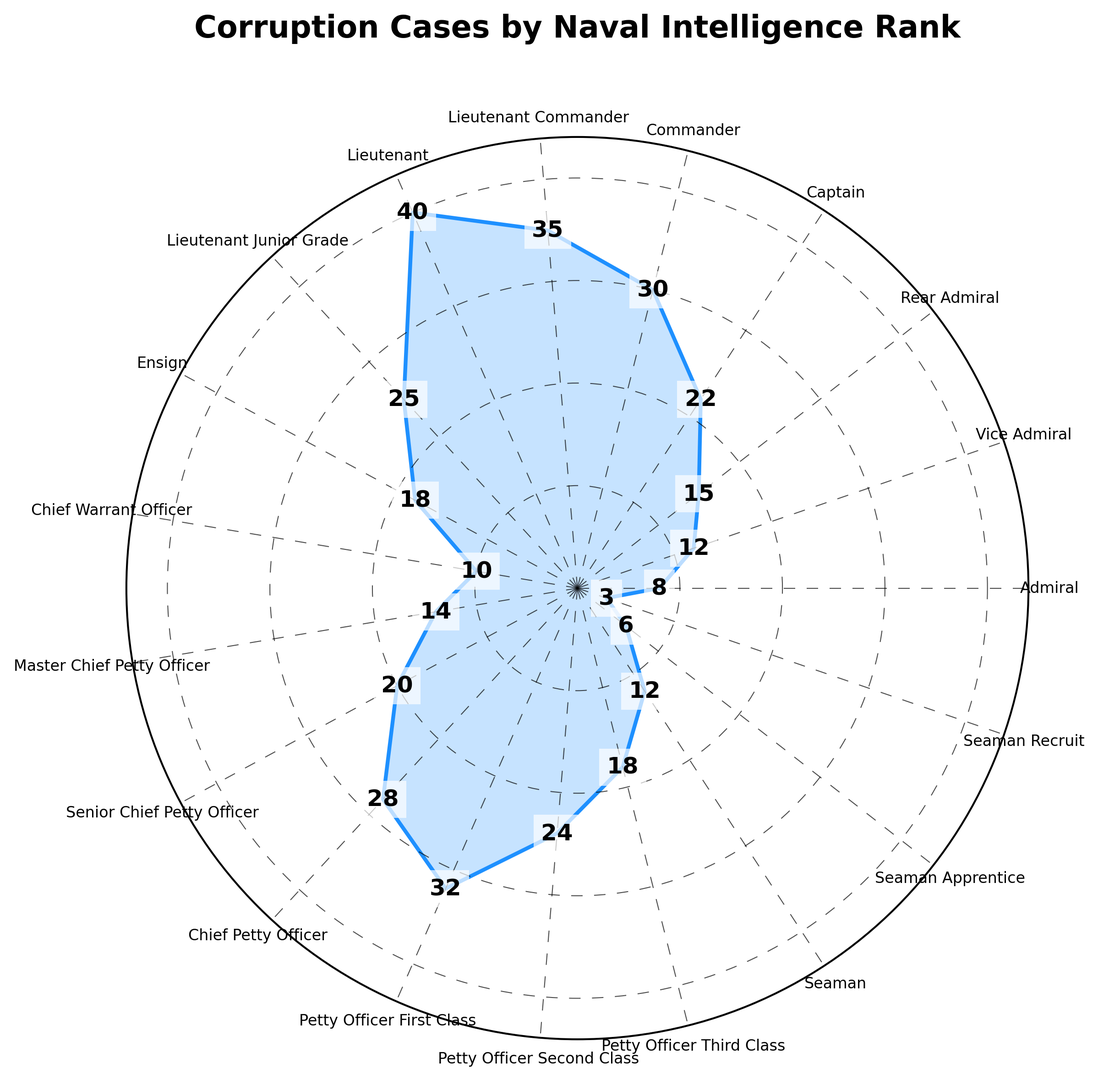What rank has the highest number of corruption cases? By looking at the visual representation, we identify that the sector extending furthest from the center indicates the greatest number of cases, which corresponds to the label "Lieutenant".
Answer: Lieutenant Which two ranks have an equal number of corruption cases? From the plot, we observe that the sectors labeled "Ensign" and "Petty Officer Third Class" extend equally far from the center, indicating the same number of cases for both ranks.
Answer: Ensign and Petty Officer Third Class What is the total number of corruption cases for the ranks "Vice Admiral" and "Rear Admiral"? By adding the cases for "Vice Admiral" (12) and "Rear Admiral" (15), we get 12 + 15 = 27.
Answer: 27 Which rank has fewer corruption cases: "Seaman" or "Master Chief Petty Officer"? Comparing the lengths of the sectors, the sector labeled "Seaman" is shorter than the sector labeled "Master Chief Petty Officer", indicating fewer cases for "Seaman".
Answer: Seaman What is the average number of corruption cases for ranks "Captain", "Commander", and "Lieutenant Commander"? Add the cases for "Captain" (22), "Commander" (30), and "Lieutenant Commander" (35), and then divide by 3. (22 + 30 + 35) / 3 = 87 / 3 = 29
Answer: 29 Which of the following ranks, "Seaman Apprentice" or "Lieutenant Junior Grade", has more cases? By comparing the lengths of the corresponding sectors, the sector labeled “Lieutenant Junior Grade” extends further, indicating more cases.
Answer: Lieutenant Junior Grade How many more corruption cases does "Chief Petty Officer" have compared to "Chief Warrant Officer"? Subtract the number of cases for "Chief Warrant Officer" (10) from "Chief Petty Officer" (28). 28 - 10 = 18
Answer: 18 What percentage of the total corruption cases does the "Lieutenant" rank represent? First, sum all cases: 8 + 12 + 15 + 22 + 30 + 35 + 40 + 25 + 18 + 10 + 14 + 20 + 28 + 32 + 24 + 18 + 12 + 6 + 3 = 372. Then, divide the cases for "Lieutenant" (40) by the total (372) and multiply by 100 to get the percentage. (40 / 372) * 100 ≈ 10.75%
Answer: 10.75% If you combine the corruption cases of all enlisted ranks (Chief Warrant Officer and below), what is the total? Add the cases for all enlisted ranks: 10 (Chief Warrant Officer) + 14 (Master Chief Petty Officer) + 20 (Senior Chief Petty Officer) + 28 (Chief Petty Officer) + 32 (Petty Officer First Class) + 24 (Petty Officer Second Class) + 18 (Petty Officer Third Class) + 12 (Seaman) + 6 (Seaman Apprentice) + 3 (Seaman Recruit). Total = 167
Answer: 167 